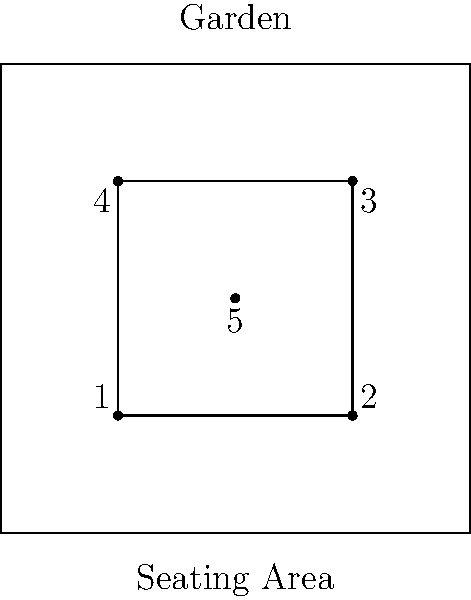In a serene garden setting, you're tasked with arranging a writer's circle for optimal creativity and comfort. The diagram shows a square garden with a central seating area. Five writers need to be seated, including yourself. Which seating position would be ideal for you as the host, considering the need to facilitate discussion and maintain a view of the garden? To determine the optimal seating arrangement, let's consider the following factors:

1. As the host, you should be in a position that allows easy interaction with all participants.
2. The host should have a good view of the garden to draw inspiration and maintain the peaceful ambiance.
3. The position should allow for easy facilitation of discussions and activities.

Analyzing the seating positions:

1. Positions 1, 2, 3, and 4 are at the corners of the seating area. While they offer good views of the garden, they might make it difficult to interact equally with all participants.
2. Position 5 is at the center of the seating area. This central location offers several advantages:
   a. It allows equal distance and easy interaction with all other participants.
   b. It provides a 360-degree view of the garden, maximizing inspiration from the surroundings.
   c. It's an ideal position for facilitating discussions and activities, as you can easily address everyone.

3. The central position also symbolically represents the heart of the writing circle, fostering a sense of unity and shared purpose.

Given these considerations, position 5 emerges as the optimal choice for you as the host of the writer's circle.
Answer: Position 5 (center) 